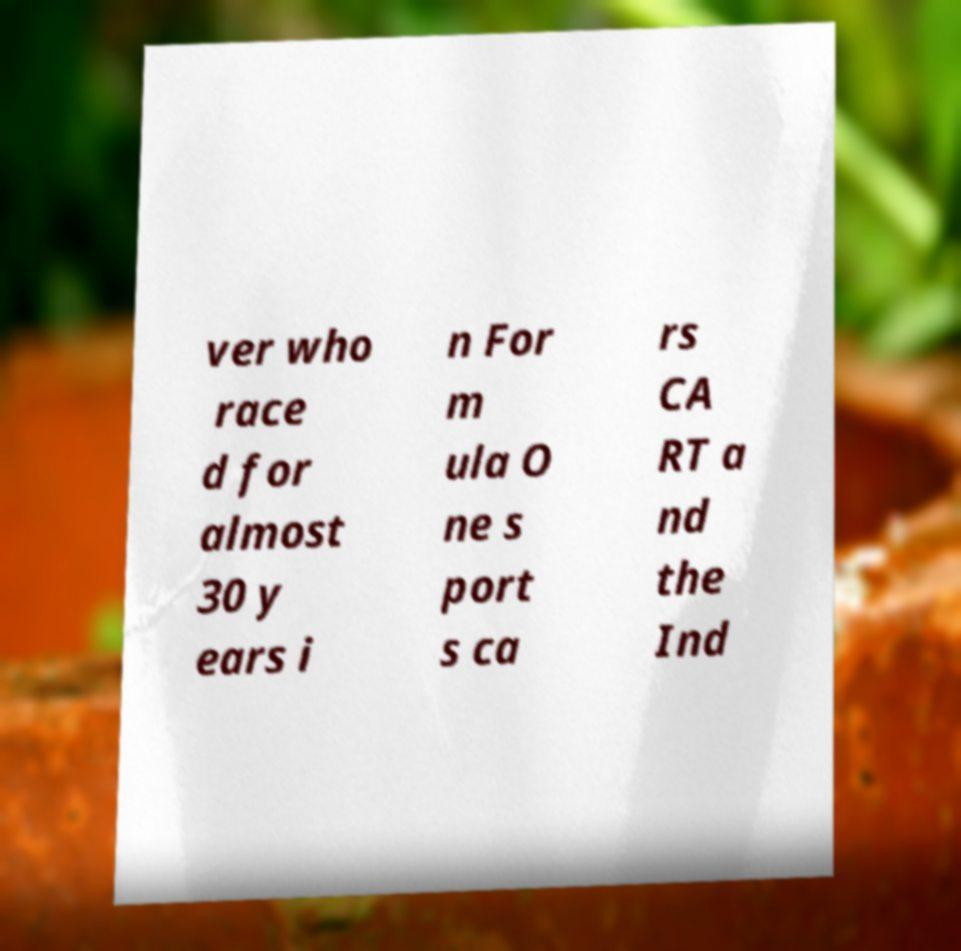What messages or text are displayed in this image? I need them in a readable, typed format. ver who race d for almost 30 y ears i n For m ula O ne s port s ca rs CA RT a nd the Ind 